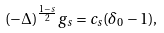<formula> <loc_0><loc_0><loc_500><loc_500>( - \Delta ) ^ { \frac { 1 - s } { 2 } } g _ { s } = c _ { s } ( \delta _ { 0 } - 1 ) ,</formula> 